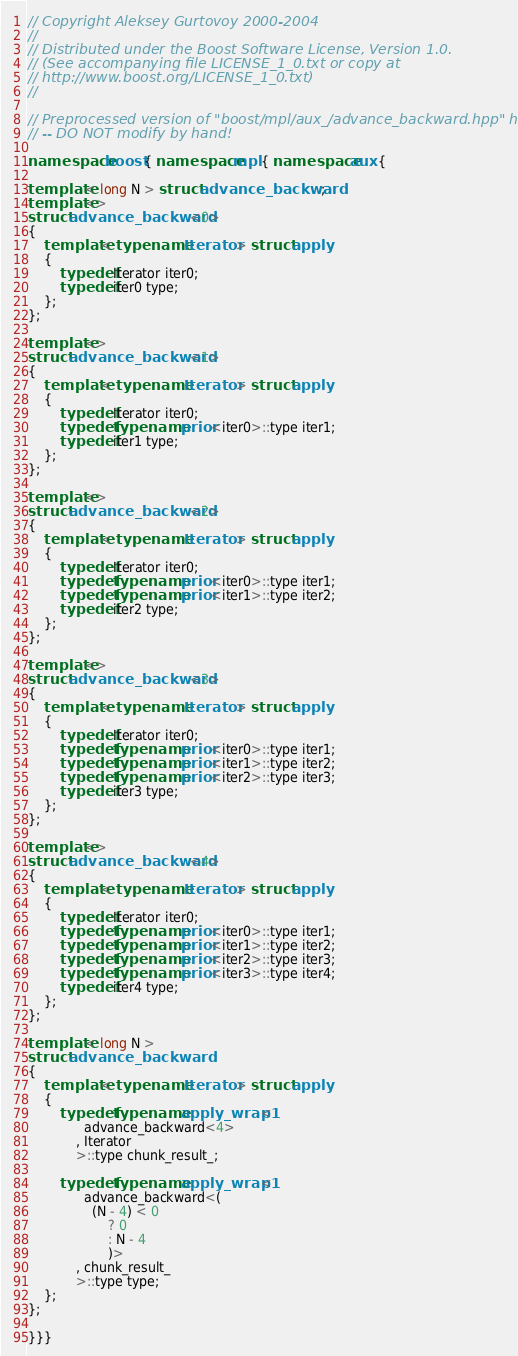Convert code to text. <code><loc_0><loc_0><loc_500><loc_500><_C++_>
// Copyright Aleksey Gurtovoy 2000-2004
//
// Distributed under the Boost Software License, Version 1.0.
// (See accompanying file LICENSE_1_0.txt or copy at
// http://www.boost.org/LICENSE_1_0.txt)
//

// Preprocessed version of "boost/mpl/aux_/advance_backward.hpp" header
// -- DO NOT modify by hand!

namespace boost { namespace mpl { namespace aux {

template< long N > struct advance_backward;
template<>
struct advance_backward<0>
{
    template< typename Iterator > struct apply
    {
        typedef Iterator iter0;
        typedef iter0 type;
    };
};

template<>
struct advance_backward<1>
{
    template< typename Iterator > struct apply
    {
        typedef Iterator iter0;
        typedef typename prior<iter0>::type iter1;
        typedef iter1 type;
    };
};

template<>
struct advance_backward<2>
{
    template< typename Iterator > struct apply
    {
        typedef Iterator iter0;
        typedef typename prior<iter0>::type iter1;
        typedef typename prior<iter1>::type iter2;
        typedef iter2 type;
    };
};

template<>
struct advance_backward<3>
{
    template< typename Iterator > struct apply
    {
        typedef Iterator iter0;
        typedef typename prior<iter0>::type iter1;
        typedef typename prior<iter1>::type iter2;
        typedef typename prior<iter2>::type iter3;
        typedef iter3 type;
    };
};

template<>
struct advance_backward<4>
{
    template< typename Iterator > struct apply
    {
        typedef Iterator iter0;
        typedef typename prior<iter0>::type iter1;
        typedef typename prior<iter1>::type iter2;
        typedef typename prior<iter2>::type iter3;
        typedef typename prior<iter3>::type iter4;
        typedef iter4 type;
    };
};

template< long N >
struct advance_backward
{
    template< typename Iterator > struct apply
    {
        typedef typename apply_wrap1<
              advance_backward<4>
            , Iterator
            >::type chunk_result_;

        typedef typename apply_wrap1<
              advance_backward<(
                (N - 4) < 0
                    ? 0
                    : N - 4
                    )>
            , chunk_result_
            >::type type;
    };
};

}}}
</code> 